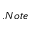Convert formula to latex. <formula><loc_0><loc_0><loc_500><loc_500>. N o t e</formula> 